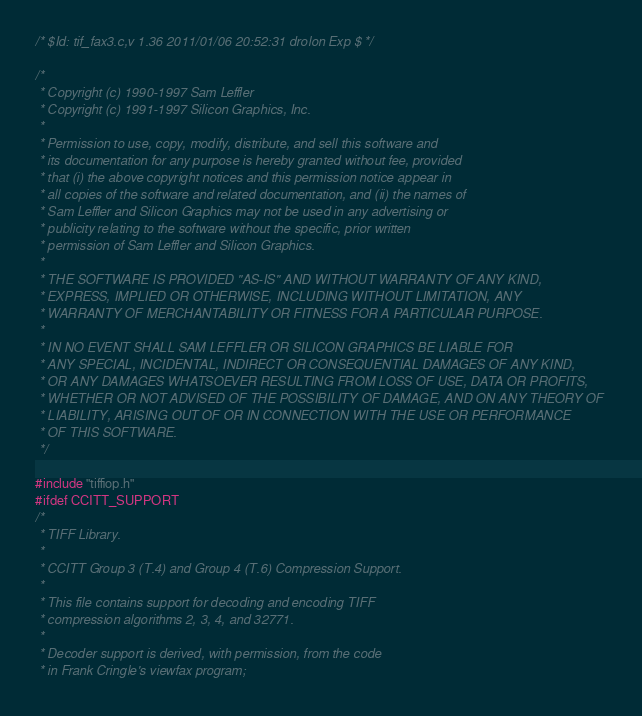<code> <loc_0><loc_0><loc_500><loc_500><_C_>/* $Id: tif_fax3.c,v 1.36 2011/01/06 20:52:31 drolon Exp $ */

/*
 * Copyright (c) 1990-1997 Sam Leffler
 * Copyright (c) 1991-1997 Silicon Graphics, Inc.
 *
 * Permission to use, copy, modify, distribute, and sell this software and 
 * its documentation for any purpose is hereby granted without fee, provided
 * that (i) the above copyright notices and this permission notice appear in
 * all copies of the software and related documentation, and (ii) the names of
 * Sam Leffler and Silicon Graphics may not be used in any advertising or
 * publicity relating to the software without the specific, prior written
 * permission of Sam Leffler and Silicon Graphics.
 * 
 * THE SOFTWARE IS PROVIDED "AS-IS" AND WITHOUT WARRANTY OF ANY KIND, 
 * EXPRESS, IMPLIED OR OTHERWISE, INCLUDING WITHOUT LIMITATION, ANY 
 * WARRANTY OF MERCHANTABILITY OR FITNESS FOR A PARTICULAR PURPOSE.  
 * 
 * IN NO EVENT SHALL SAM LEFFLER OR SILICON GRAPHICS BE LIABLE FOR
 * ANY SPECIAL, INCIDENTAL, INDIRECT OR CONSEQUENTIAL DAMAGES OF ANY KIND,
 * OR ANY DAMAGES WHATSOEVER RESULTING FROM LOSS OF USE, DATA OR PROFITS,
 * WHETHER OR NOT ADVISED OF THE POSSIBILITY OF DAMAGE, AND ON ANY THEORY OF 
 * LIABILITY, ARISING OUT OF OR IN CONNECTION WITH THE USE OR PERFORMANCE 
 * OF THIS SOFTWARE.
 */

#include "tiffiop.h"
#ifdef CCITT_SUPPORT
/*
 * TIFF Library.
 *
 * CCITT Group 3 (T.4) and Group 4 (T.6) Compression Support.
 *
 * This file contains support for decoding and encoding TIFF
 * compression algorithms 2, 3, 4, and 32771.
 *
 * Decoder support is derived, with permission, from the code
 * in Frank Cringle's viewfax program;</code> 